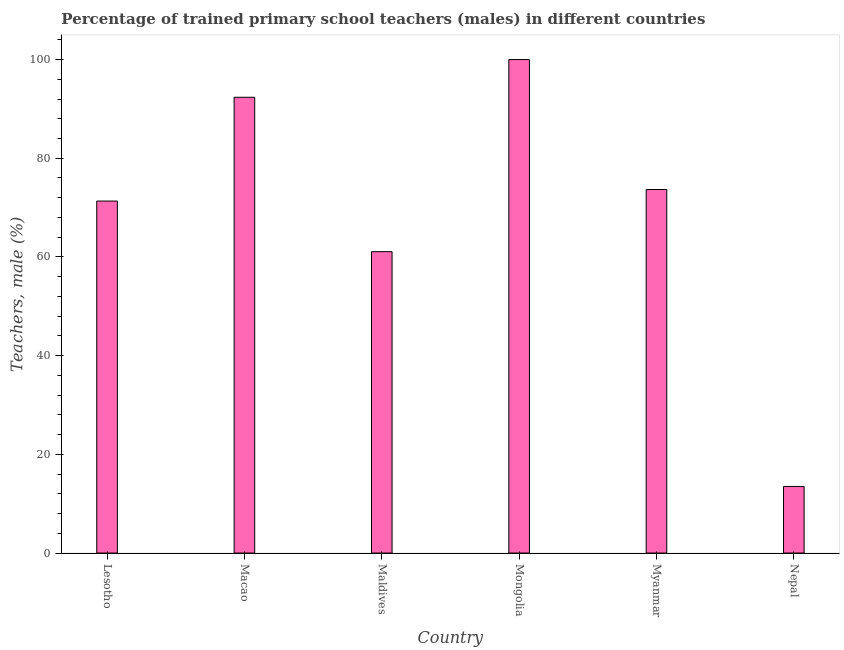What is the title of the graph?
Your answer should be compact. Percentage of trained primary school teachers (males) in different countries. What is the label or title of the Y-axis?
Keep it short and to the point. Teachers, male (%). What is the percentage of trained male teachers in Macao?
Ensure brevity in your answer.  92.36. Across all countries, what is the minimum percentage of trained male teachers?
Keep it short and to the point. 13.49. In which country was the percentage of trained male teachers maximum?
Offer a very short reply. Mongolia. In which country was the percentage of trained male teachers minimum?
Give a very brief answer. Nepal. What is the sum of the percentage of trained male teachers?
Keep it short and to the point. 411.91. What is the difference between the percentage of trained male teachers in Lesotho and Nepal?
Provide a succinct answer. 57.83. What is the average percentage of trained male teachers per country?
Keep it short and to the point. 68.65. What is the median percentage of trained male teachers?
Your answer should be compact. 72.5. In how many countries, is the percentage of trained male teachers greater than 88 %?
Give a very brief answer. 2. What is the ratio of the percentage of trained male teachers in Maldives to that in Mongolia?
Offer a very short reply. 0.61. What is the difference between the highest and the second highest percentage of trained male teachers?
Your answer should be very brief. 7.64. What is the difference between the highest and the lowest percentage of trained male teachers?
Keep it short and to the point. 86.51. In how many countries, is the percentage of trained male teachers greater than the average percentage of trained male teachers taken over all countries?
Provide a succinct answer. 4. Are all the bars in the graph horizontal?
Offer a very short reply. No. Are the values on the major ticks of Y-axis written in scientific E-notation?
Provide a succinct answer. No. What is the Teachers, male (%) of Lesotho?
Your answer should be very brief. 71.33. What is the Teachers, male (%) in Macao?
Offer a very short reply. 92.36. What is the Teachers, male (%) in Maldives?
Make the answer very short. 61.07. What is the Teachers, male (%) of Myanmar?
Provide a succinct answer. 73.67. What is the Teachers, male (%) of Nepal?
Make the answer very short. 13.49. What is the difference between the Teachers, male (%) in Lesotho and Macao?
Offer a terse response. -21.03. What is the difference between the Teachers, male (%) in Lesotho and Maldives?
Your response must be concise. 10.26. What is the difference between the Teachers, male (%) in Lesotho and Mongolia?
Make the answer very short. -28.67. What is the difference between the Teachers, male (%) in Lesotho and Myanmar?
Your answer should be compact. -2.34. What is the difference between the Teachers, male (%) in Lesotho and Nepal?
Make the answer very short. 57.83. What is the difference between the Teachers, male (%) in Macao and Maldives?
Provide a short and direct response. 31.29. What is the difference between the Teachers, male (%) in Macao and Mongolia?
Provide a succinct answer. -7.64. What is the difference between the Teachers, male (%) in Macao and Myanmar?
Your answer should be compact. 18.69. What is the difference between the Teachers, male (%) in Macao and Nepal?
Ensure brevity in your answer.  78.86. What is the difference between the Teachers, male (%) in Maldives and Mongolia?
Ensure brevity in your answer.  -38.93. What is the difference between the Teachers, male (%) in Maldives and Myanmar?
Your response must be concise. -12.6. What is the difference between the Teachers, male (%) in Maldives and Nepal?
Offer a terse response. 47.58. What is the difference between the Teachers, male (%) in Mongolia and Myanmar?
Offer a very short reply. 26.33. What is the difference between the Teachers, male (%) in Mongolia and Nepal?
Provide a short and direct response. 86.51. What is the difference between the Teachers, male (%) in Myanmar and Nepal?
Offer a terse response. 60.17. What is the ratio of the Teachers, male (%) in Lesotho to that in Macao?
Your answer should be very brief. 0.77. What is the ratio of the Teachers, male (%) in Lesotho to that in Maldives?
Provide a succinct answer. 1.17. What is the ratio of the Teachers, male (%) in Lesotho to that in Mongolia?
Your response must be concise. 0.71. What is the ratio of the Teachers, male (%) in Lesotho to that in Nepal?
Offer a terse response. 5.29. What is the ratio of the Teachers, male (%) in Macao to that in Maldives?
Provide a succinct answer. 1.51. What is the ratio of the Teachers, male (%) in Macao to that in Mongolia?
Give a very brief answer. 0.92. What is the ratio of the Teachers, male (%) in Macao to that in Myanmar?
Offer a very short reply. 1.25. What is the ratio of the Teachers, male (%) in Macao to that in Nepal?
Your answer should be compact. 6.84. What is the ratio of the Teachers, male (%) in Maldives to that in Mongolia?
Offer a very short reply. 0.61. What is the ratio of the Teachers, male (%) in Maldives to that in Myanmar?
Ensure brevity in your answer.  0.83. What is the ratio of the Teachers, male (%) in Maldives to that in Nepal?
Ensure brevity in your answer.  4.53. What is the ratio of the Teachers, male (%) in Mongolia to that in Myanmar?
Offer a very short reply. 1.36. What is the ratio of the Teachers, male (%) in Mongolia to that in Nepal?
Keep it short and to the point. 7.41. What is the ratio of the Teachers, male (%) in Myanmar to that in Nepal?
Keep it short and to the point. 5.46. 